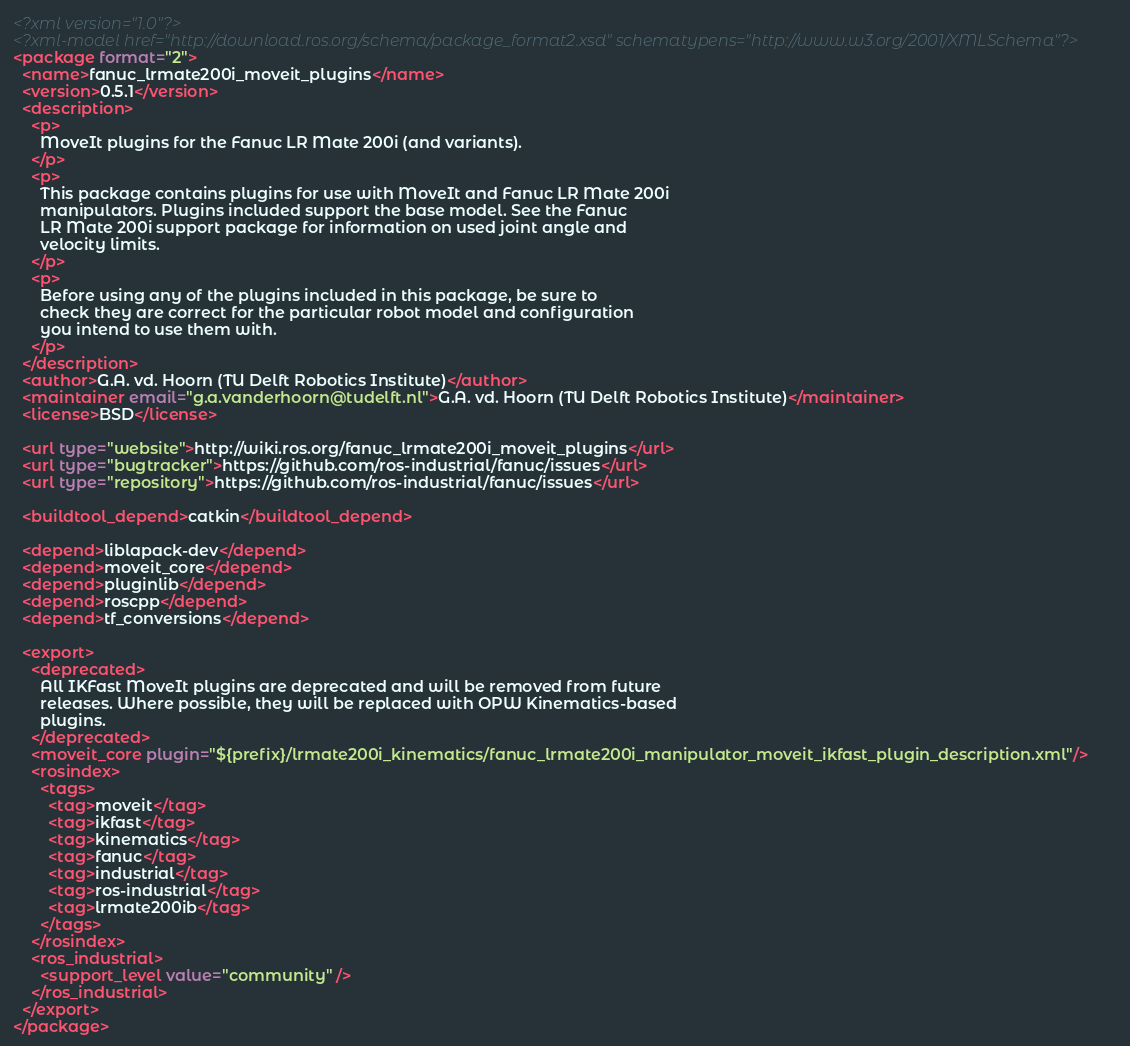<code> <loc_0><loc_0><loc_500><loc_500><_XML_><?xml version="1.0"?>
<?xml-model href="http://download.ros.org/schema/package_format2.xsd" schematypens="http://www.w3.org/2001/XMLSchema"?>
<package format="2">
  <name>fanuc_lrmate200i_moveit_plugins</name>
  <version>0.5.1</version>
  <description>
    <p>
      MoveIt plugins for the Fanuc LR Mate 200i (and variants).
    </p>
    <p>
      This package contains plugins for use with MoveIt and Fanuc LR Mate 200i
      manipulators. Plugins included support the base model. See the Fanuc
      LR Mate 200i support package for information on used joint angle and
      velocity limits.
    </p>
    <p>
      Before using any of the plugins included in this package, be sure to
      check they are correct for the particular robot model and configuration
      you intend to use them with.
    </p>
  </description>
  <author>G.A. vd. Hoorn (TU Delft Robotics Institute)</author>
  <maintainer email="g.a.vanderhoorn@tudelft.nl">G.A. vd. Hoorn (TU Delft Robotics Institute)</maintainer>
  <license>BSD</license>

  <url type="website">http://wiki.ros.org/fanuc_lrmate200i_moveit_plugins</url>
  <url type="bugtracker">https://github.com/ros-industrial/fanuc/issues</url>
  <url type="repository">https://github.com/ros-industrial/fanuc/issues</url>

  <buildtool_depend>catkin</buildtool_depend>

  <depend>liblapack-dev</depend>
  <depend>moveit_core</depend>
  <depend>pluginlib</depend>
  <depend>roscpp</depend>
  <depend>tf_conversions</depend>

  <export>
    <deprecated>
      All IKFast MoveIt plugins are deprecated and will be removed from future
      releases. Where possible, they will be replaced with OPW Kinematics-based
      plugins.
    </deprecated>
    <moveit_core plugin="${prefix}/lrmate200i_kinematics/fanuc_lrmate200i_manipulator_moveit_ikfast_plugin_description.xml"/>
    <rosindex>
      <tags>
        <tag>moveit</tag>
        <tag>ikfast</tag>
        <tag>kinematics</tag>
        <tag>fanuc</tag>
        <tag>industrial</tag>
        <tag>ros-industrial</tag>
        <tag>lrmate200ib</tag>
      </tags>
    </rosindex>
    <ros_industrial>
      <support_level value="community" />
    </ros_industrial>
  </export>
</package>
</code> 